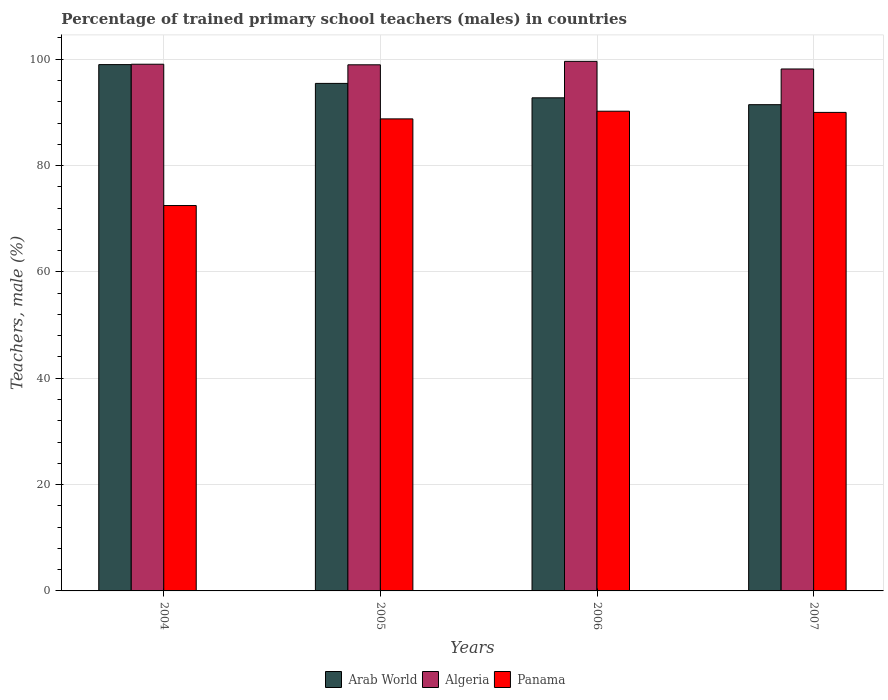How many different coloured bars are there?
Offer a terse response. 3. Are the number of bars per tick equal to the number of legend labels?
Offer a terse response. Yes. How many bars are there on the 4th tick from the right?
Give a very brief answer. 3. In how many cases, is the number of bars for a given year not equal to the number of legend labels?
Ensure brevity in your answer.  0. What is the percentage of trained primary school teachers (males) in Arab World in 2007?
Give a very brief answer. 91.45. Across all years, what is the maximum percentage of trained primary school teachers (males) in Arab World?
Give a very brief answer. 98.98. Across all years, what is the minimum percentage of trained primary school teachers (males) in Arab World?
Offer a terse response. 91.45. In which year was the percentage of trained primary school teachers (males) in Panama maximum?
Offer a terse response. 2006. What is the total percentage of trained primary school teachers (males) in Panama in the graph?
Offer a very short reply. 341.47. What is the difference between the percentage of trained primary school teachers (males) in Arab World in 2004 and that in 2006?
Make the answer very short. 6.25. What is the difference between the percentage of trained primary school teachers (males) in Algeria in 2007 and the percentage of trained primary school teachers (males) in Panama in 2006?
Make the answer very short. 7.94. What is the average percentage of trained primary school teachers (males) in Algeria per year?
Offer a terse response. 98.94. In the year 2007, what is the difference between the percentage of trained primary school teachers (males) in Panama and percentage of trained primary school teachers (males) in Arab World?
Keep it short and to the point. -1.45. What is the ratio of the percentage of trained primary school teachers (males) in Algeria in 2004 to that in 2007?
Keep it short and to the point. 1.01. Is the percentage of trained primary school teachers (males) in Panama in 2004 less than that in 2007?
Provide a succinct answer. Yes. Is the difference between the percentage of trained primary school teachers (males) in Panama in 2005 and 2006 greater than the difference between the percentage of trained primary school teachers (males) in Arab World in 2005 and 2006?
Offer a terse response. No. What is the difference between the highest and the second highest percentage of trained primary school teachers (males) in Panama?
Make the answer very short. 0.23. What is the difference between the highest and the lowest percentage of trained primary school teachers (males) in Algeria?
Offer a terse response. 1.43. In how many years, is the percentage of trained primary school teachers (males) in Algeria greater than the average percentage of trained primary school teachers (males) in Algeria taken over all years?
Ensure brevity in your answer.  3. Is the sum of the percentage of trained primary school teachers (males) in Algeria in 2004 and 2006 greater than the maximum percentage of trained primary school teachers (males) in Arab World across all years?
Give a very brief answer. Yes. What does the 3rd bar from the left in 2007 represents?
Provide a short and direct response. Panama. What does the 2nd bar from the right in 2006 represents?
Offer a very short reply. Algeria. Is it the case that in every year, the sum of the percentage of trained primary school teachers (males) in Panama and percentage of trained primary school teachers (males) in Arab World is greater than the percentage of trained primary school teachers (males) in Algeria?
Ensure brevity in your answer.  Yes. How many bars are there?
Ensure brevity in your answer.  12. Are all the bars in the graph horizontal?
Offer a very short reply. No. How many years are there in the graph?
Offer a very short reply. 4. Does the graph contain grids?
Your answer should be compact. Yes. Where does the legend appear in the graph?
Your answer should be very brief. Bottom center. How many legend labels are there?
Your answer should be very brief. 3. How are the legend labels stacked?
Your response must be concise. Horizontal. What is the title of the graph?
Your answer should be compact. Percentage of trained primary school teachers (males) in countries. What is the label or title of the Y-axis?
Provide a short and direct response. Teachers, male (%). What is the Teachers, male (%) in Arab World in 2004?
Make the answer very short. 98.98. What is the Teachers, male (%) in Algeria in 2004?
Ensure brevity in your answer.  99.06. What is the Teachers, male (%) of Panama in 2004?
Give a very brief answer. 72.48. What is the Teachers, male (%) of Arab World in 2005?
Offer a terse response. 95.45. What is the Teachers, male (%) of Algeria in 2005?
Provide a short and direct response. 98.95. What is the Teachers, male (%) in Panama in 2005?
Your answer should be very brief. 88.78. What is the Teachers, male (%) in Arab World in 2006?
Your answer should be compact. 92.74. What is the Teachers, male (%) of Algeria in 2006?
Offer a very short reply. 99.6. What is the Teachers, male (%) in Panama in 2006?
Ensure brevity in your answer.  90.22. What is the Teachers, male (%) in Arab World in 2007?
Give a very brief answer. 91.45. What is the Teachers, male (%) in Algeria in 2007?
Provide a succinct answer. 98.16. What is the Teachers, male (%) of Panama in 2007?
Make the answer very short. 90. Across all years, what is the maximum Teachers, male (%) in Arab World?
Provide a short and direct response. 98.98. Across all years, what is the maximum Teachers, male (%) in Algeria?
Give a very brief answer. 99.6. Across all years, what is the maximum Teachers, male (%) of Panama?
Provide a short and direct response. 90.22. Across all years, what is the minimum Teachers, male (%) of Arab World?
Ensure brevity in your answer.  91.45. Across all years, what is the minimum Teachers, male (%) of Algeria?
Your response must be concise. 98.16. Across all years, what is the minimum Teachers, male (%) of Panama?
Your answer should be very brief. 72.48. What is the total Teachers, male (%) in Arab World in the graph?
Your answer should be very brief. 378.62. What is the total Teachers, male (%) of Algeria in the graph?
Ensure brevity in your answer.  395.77. What is the total Teachers, male (%) in Panama in the graph?
Make the answer very short. 341.47. What is the difference between the Teachers, male (%) of Arab World in 2004 and that in 2005?
Offer a very short reply. 3.54. What is the difference between the Teachers, male (%) of Algeria in 2004 and that in 2005?
Your answer should be very brief. 0.11. What is the difference between the Teachers, male (%) in Panama in 2004 and that in 2005?
Your answer should be very brief. -16.3. What is the difference between the Teachers, male (%) in Arab World in 2004 and that in 2006?
Give a very brief answer. 6.25. What is the difference between the Teachers, male (%) of Algeria in 2004 and that in 2006?
Offer a very short reply. -0.54. What is the difference between the Teachers, male (%) in Panama in 2004 and that in 2006?
Offer a terse response. -17.74. What is the difference between the Teachers, male (%) in Arab World in 2004 and that in 2007?
Offer a very short reply. 7.54. What is the difference between the Teachers, male (%) of Algeria in 2004 and that in 2007?
Your answer should be compact. 0.9. What is the difference between the Teachers, male (%) in Panama in 2004 and that in 2007?
Offer a terse response. -17.52. What is the difference between the Teachers, male (%) in Arab World in 2005 and that in 2006?
Ensure brevity in your answer.  2.71. What is the difference between the Teachers, male (%) in Algeria in 2005 and that in 2006?
Keep it short and to the point. -0.65. What is the difference between the Teachers, male (%) in Panama in 2005 and that in 2006?
Your answer should be compact. -1.44. What is the difference between the Teachers, male (%) in Arab World in 2005 and that in 2007?
Your answer should be compact. 4. What is the difference between the Teachers, male (%) in Algeria in 2005 and that in 2007?
Make the answer very short. 0.79. What is the difference between the Teachers, male (%) in Panama in 2005 and that in 2007?
Your answer should be very brief. -1.22. What is the difference between the Teachers, male (%) in Arab World in 2006 and that in 2007?
Give a very brief answer. 1.29. What is the difference between the Teachers, male (%) in Algeria in 2006 and that in 2007?
Give a very brief answer. 1.43. What is the difference between the Teachers, male (%) of Panama in 2006 and that in 2007?
Offer a very short reply. 0.23. What is the difference between the Teachers, male (%) of Arab World in 2004 and the Teachers, male (%) of Algeria in 2005?
Offer a very short reply. 0.04. What is the difference between the Teachers, male (%) in Arab World in 2004 and the Teachers, male (%) in Panama in 2005?
Give a very brief answer. 10.21. What is the difference between the Teachers, male (%) of Algeria in 2004 and the Teachers, male (%) of Panama in 2005?
Offer a terse response. 10.28. What is the difference between the Teachers, male (%) in Arab World in 2004 and the Teachers, male (%) in Algeria in 2006?
Your answer should be very brief. -0.61. What is the difference between the Teachers, male (%) in Arab World in 2004 and the Teachers, male (%) in Panama in 2006?
Make the answer very short. 8.76. What is the difference between the Teachers, male (%) of Algeria in 2004 and the Teachers, male (%) of Panama in 2006?
Your answer should be very brief. 8.84. What is the difference between the Teachers, male (%) in Arab World in 2004 and the Teachers, male (%) in Algeria in 2007?
Your answer should be very brief. 0.82. What is the difference between the Teachers, male (%) in Arab World in 2004 and the Teachers, male (%) in Panama in 2007?
Offer a very short reply. 8.99. What is the difference between the Teachers, male (%) of Algeria in 2004 and the Teachers, male (%) of Panama in 2007?
Provide a succinct answer. 9.06. What is the difference between the Teachers, male (%) in Arab World in 2005 and the Teachers, male (%) in Algeria in 2006?
Your answer should be very brief. -4.15. What is the difference between the Teachers, male (%) of Arab World in 2005 and the Teachers, male (%) of Panama in 2006?
Give a very brief answer. 5.23. What is the difference between the Teachers, male (%) of Algeria in 2005 and the Teachers, male (%) of Panama in 2006?
Provide a short and direct response. 8.73. What is the difference between the Teachers, male (%) in Arab World in 2005 and the Teachers, male (%) in Algeria in 2007?
Make the answer very short. -2.71. What is the difference between the Teachers, male (%) of Arab World in 2005 and the Teachers, male (%) of Panama in 2007?
Keep it short and to the point. 5.45. What is the difference between the Teachers, male (%) in Algeria in 2005 and the Teachers, male (%) in Panama in 2007?
Keep it short and to the point. 8.95. What is the difference between the Teachers, male (%) in Arab World in 2006 and the Teachers, male (%) in Algeria in 2007?
Keep it short and to the point. -5.42. What is the difference between the Teachers, male (%) of Arab World in 2006 and the Teachers, male (%) of Panama in 2007?
Give a very brief answer. 2.74. What is the difference between the Teachers, male (%) of Algeria in 2006 and the Teachers, male (%) of Panama in 2007?
Your answer should be very brief. 9.6. What is the average Teachers, male (%) of Arab World per year?
Make the answer very short. 94.66. What is the average Teachers, male (%) of Algeria per year?
Your answer should be compact. 98.94. What is the average Teachers, male (%) of Panama per year?
Provide a succinct answer. 85.37. In the year 2004, what is the difference between the Teachers, male (%) in Arab World and Teachers, male (%) in Algeria?
Provide a short and direct response. -0.07. In the year 2004, what is the difference between the Teachers, male (%) of Arab World and Teachers, male (%) of Panama?
Give a very brief answer. 26.51. In the year 2004, what is the difference between the Teachers, male (%) of Algeria and Teachers, male (%) of Panama?
Ensure brevity in your answer.  26.58. In the year 2005, what is the difference between the Teachers, male (%) of Arab World and Teachers, male (%) of Algeria?
Your answer should be very brief. -3.5. In the year 2005, what is the difference between the Teachers, male (%) in Arab World and Teachers, male (%) in Panama?
Provide a succinct answer. 6.67. In the year 2005, what is the difference between the Teachers, male (%) in Algeria and Teachers, male (%) in Panama?
Keep it short and to the point. 10.17. In the year 2006, what is the difference between the Teachers, male (%) in Arab World and Teachers, male (%) in Algeria?
Keep it short and to the point. -6.86. In the year 2006, what is the difference between the Teachers, male (%) of Arab World and Teachers, male (%) of Panama?
Offer a very short reply. 2.52. In the year 2006, what is the difference between the Teachers, male (%) in Algeria and Teachers, male (%) in Panama?
Provide a short and direct response. 9.38. In the year 2007, what is the difference between the Teachers, male (%) of Arab World and Teachers, male (%) of Algeria?
Keep it short and to the point. -6.71. In the year 2007, what is the difference between the Teachers, male (%) in Arab World and Teachers, male (%) in Panama?
Provide a short and direct response. 1.45. In the year 2007, what is the difference between the Teachers, male (%) of Algeria and Teachers, male (%) of Panama?
Keep it short and to the point. 8.17. What is the ratio of the Teachers, male (%) in Arab World in 2004 to that in 2005?
Provide a short and direct response. 1.04. What is the ratio of the Teachers, male (%) of Panama in 2004 to that in 2005?
Your answer should be compact. 0.82. What is the ratio of the Teachers, male (%) of Arab World in 2004 to that in 2006?
Offer a very short reply. 1.07. What is the ratio of the Teachers, male (%) in Panama in 2004 to that in 2006?
Make the answer very short. 0.8. What is the ratio of the Teachers, male (%) of Arab World in 2004 to that in 2007?
Offer a terse response. 1.08. What is the ratio of the Teachers, male (%) of Algeria in 2004 to that in 2007?
Provide a short and direct response. 1.01. What is the ratio of the Teachers, male (%) of Panama in 2004 to that in 2007?
Your answer should be compact. 0.81. What is the ratio of the Teachers, male (%) of Arab World in 2005 to that in 2006?
Your answer should be very brief. 1.03. What is the ratio of the Teachers, male (%) of Algeria in 2005 to that in 2006?
Provide a short and direct response. 0.99. What is the ratio of the Teachers, male (%) in Arab World in 2005 to that in 2007?
Make the answer very short. 1.04. What is the ratio of the Teachers, male (%) in Algeria in 2005 to that in 2007?
Your answer should be compact. 1.01. What is the ratio of the Teachers, male (%) of Panama in 2005 to that in 2007?
Make the answer very short. 0.99. What is the ratio of the Teachers, male (%) in Arab World in 2006 to that in 2007?
Your answer should be very brief. 1.01. What is the ratio of the Teachers, male (%) in Algeria in 2006 to that in 2007?
Keep it short and to the point. 1.01. What is the difference between the highest and the second highest Teachers, male (%) of Arab World?
Ensure brevity in your answer.  3.54. What is the difference between the highest and the second highest Teachers, male (%) in Algeria?
Offer a very short reply. 0.54. What is the difference between the highest and the second highest Teachers, male (%) of Panama?
Provide a succinct answer. 0.23. What is the difference between the highest and the lowest Teachers, male (%) of Arab World?
Keep it short and to the point. 7.54. What is the difference between the highest and the lowest Teachers, male (%) of Algeria?
Offer a terse response. 1.43. What is the difference between the highest and the lowest Teachers, male (%) of Panama?
Ensure brevity in your answer.  17.74. 